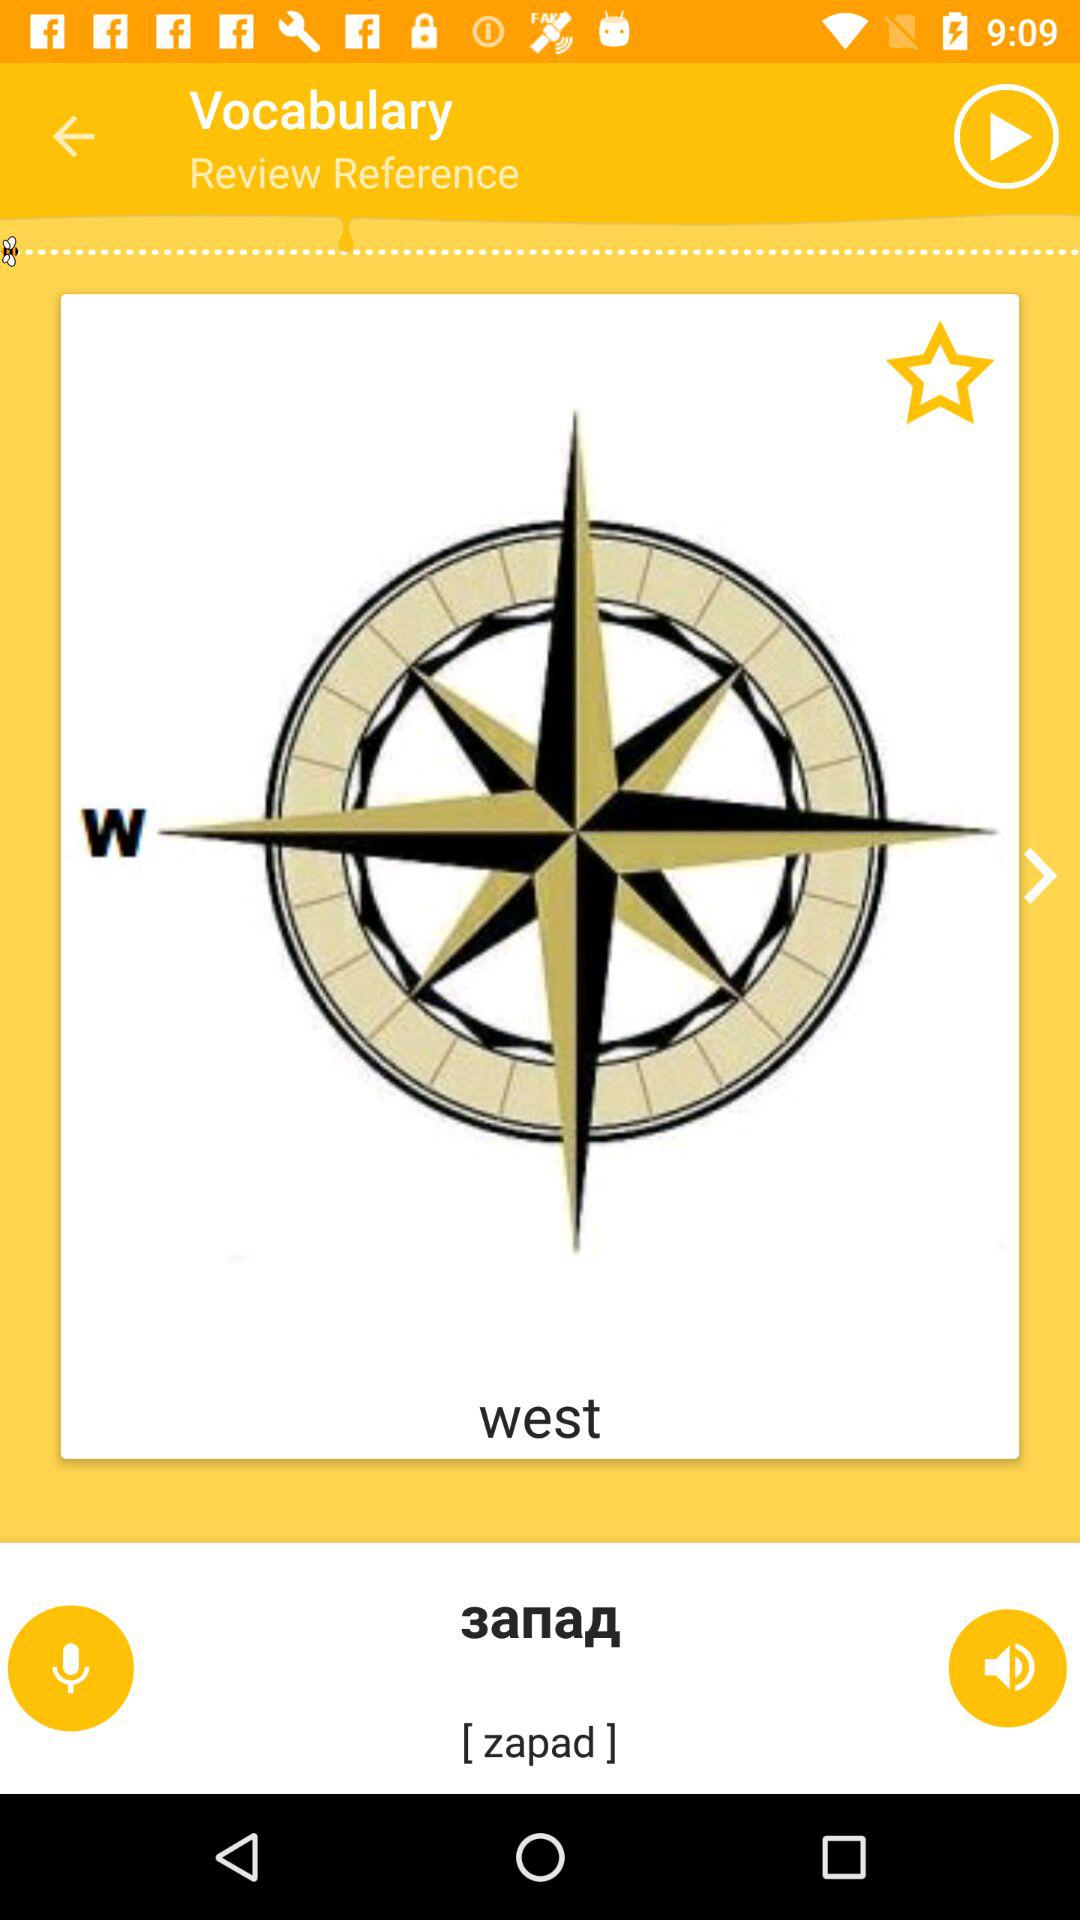Which direction is shown in the application? The direction that is shown in the application is west. 